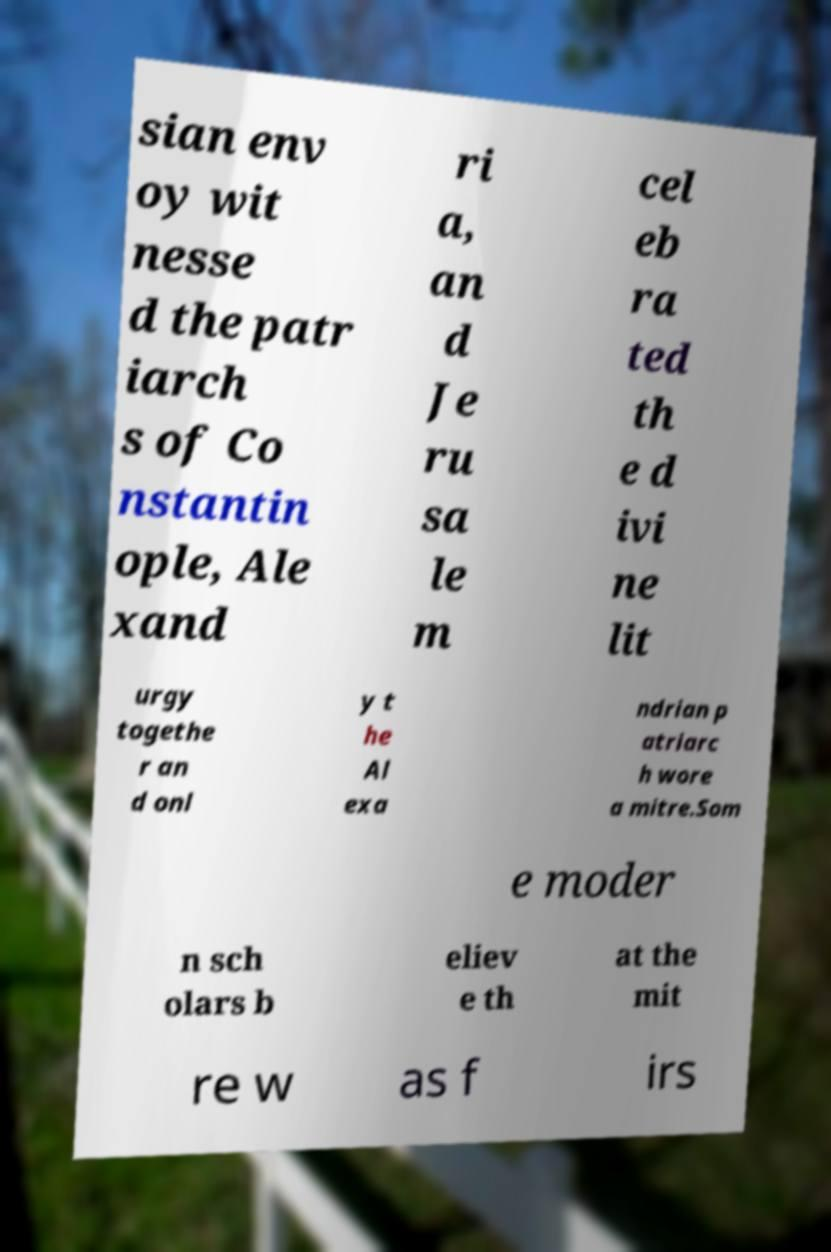Please read and relay the text visible in this image. What does it say? sian env oy wit nesse d the patr iarch s of Co nstantin ople, Ale xand ri a, an d Je ru sa le m cel eb ra ted th e d ivi ne lit urgy togethe r an d onl y t he Al exa ndrian p atriarc h wore a mitre.Som e moder n sch olars b eliev e th at the mit re w as f irs 